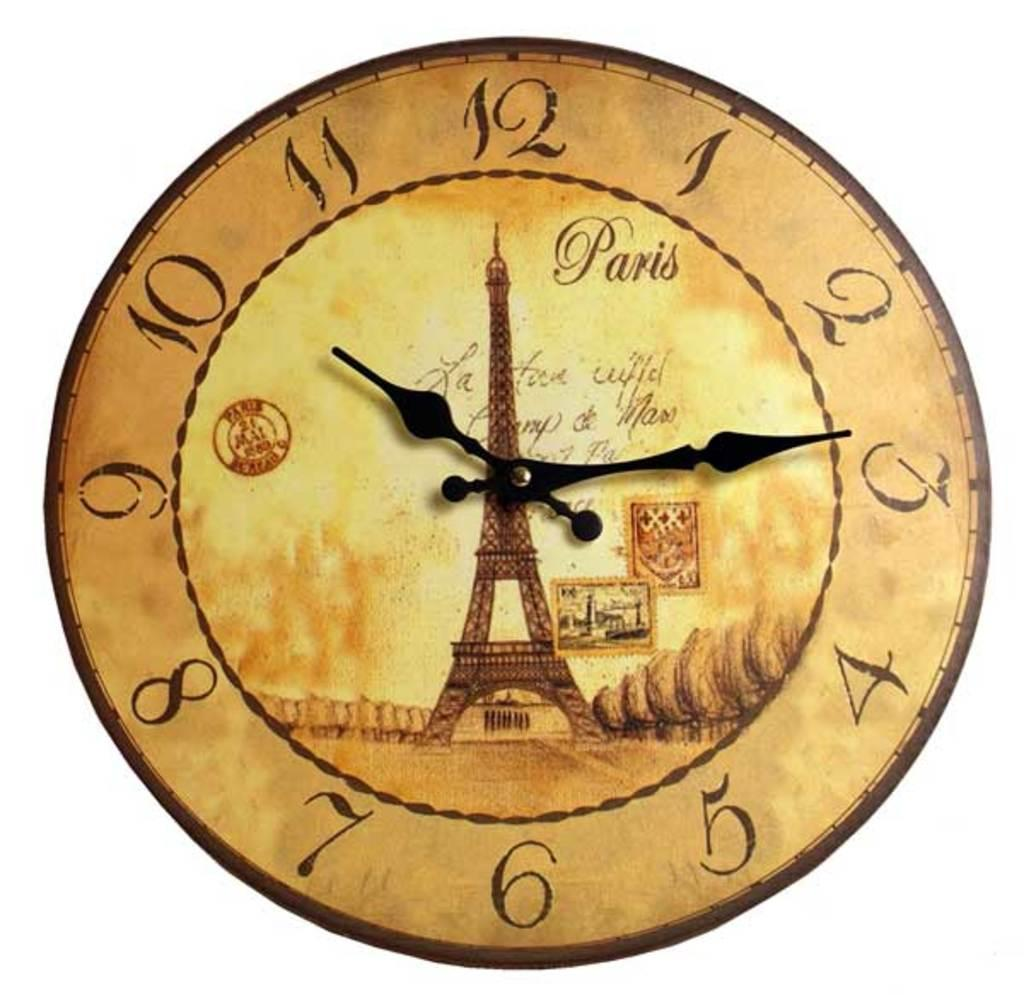<image>
Create a compact narrative representing the image presented. A clock with the Eiffel tower on it says Paris. 